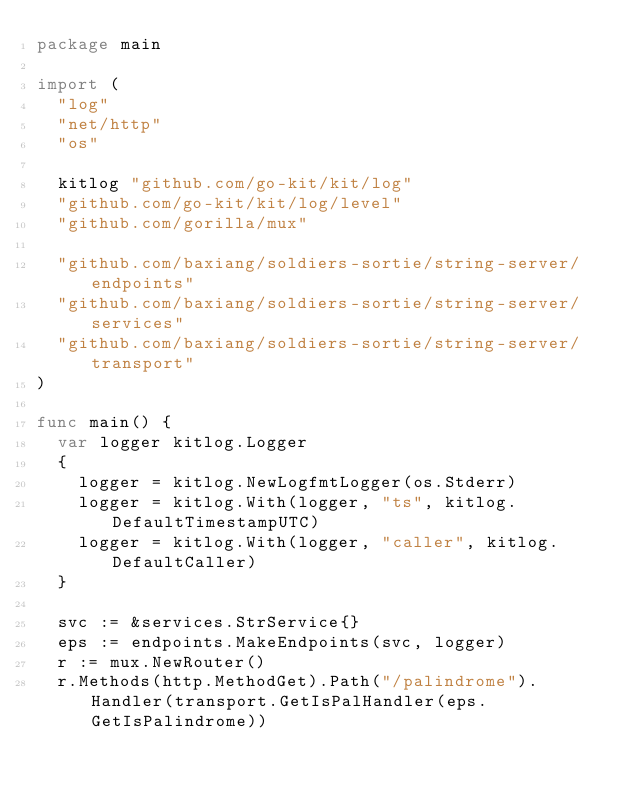Convert code to text. <code><loc_0><loc_0><loc_500><loc_500><_Go_>package main

import (
	"log"
	"net/http"
	"os"

	kitlog "github.com/go-kit/kit/log"
	"github.com/go-kit/kit/log/level"
	"github.com/gorilla/mux"

	"github.com/baxiang/soldiers-sortie/string-server/endpoints"
	"github.com/baxiang/soldiers-sortie/string-server/services"
	"github.com/baxiang/soldiers-sortie/string-server/transport"
)

func main() {
	var logger kitlog.Logger
	{
		logger = kitlog.NewLogfmtLogger(os.Stderr)
		logger = kitlog.With(logger, "ts", kitlog.DefaultTimestampUTC)
		logger = kitlog.With(logger, "caller", kitlog.DefaultCaller)
	}

	svc := &services.StrService{}
	eps := endpoints.MakeEndpoints(svc, logger)
	r := mux.NewRouter()
	r.Methods(http.MethodGet).Path("/palindrome").Handler(transport.GetIsPalHandler(eps.GetIsPalindrome))</code> 